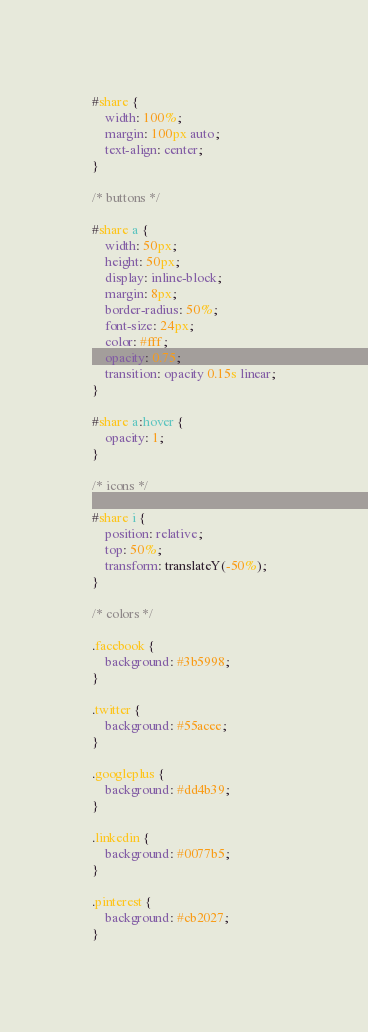Convert code to text. <code><loc_0><loc_0><loc_500><loc_500><_CSS_>
#share {
	width: 100%;
  	margin: 100px auto;
  	text-align: center;
}

/* buttons */

#share a {
	width: 50px;
  	height: 50px;
  	display: inline-block;
  	margin: 8px;
  	border-radius: 50%;
  	font-size: 24px;
  	color: #fff;
	opacity: 0.75;
	transition: opacity 0.15s linear;
}

#share a:hover {
	opacity: 1;
}

/* icons */

#share i {
  	position: relative;
  	top: 50%;
  	transform: translateY(-50%);
}

/* colors */

.facebook {
 	background: #3b5998;
}

.twitter {
  	background: #55acee;
}

.googleplus {
  	background: #dd4b39;
}

.linkedin {
  	background: #0077b5;
}

.pinterest {
  	background: #cb2027;
}</code> 